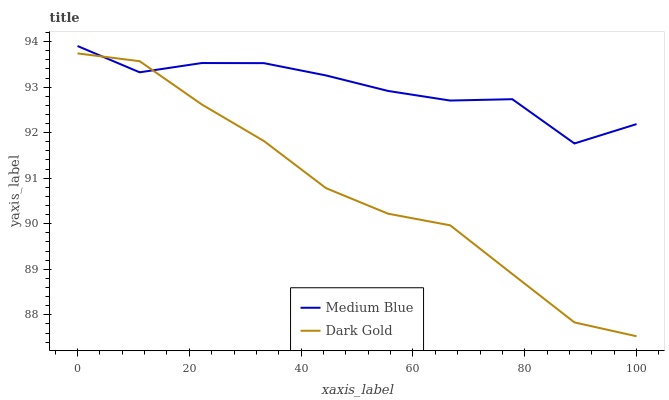Does Dark Gold have the minimum area under the curve?
Answer yes or no. Yes. Does Medium Blue have the maximum area under the curve?
Answer yes or no. Yes. Does Dark Gold have the maximum area under the curve?
Answer yes or no. No. Is Dark Gold the smoothest?
Answer yes or no. Yes. Is Medium Blue the roughest?
Answer yes or no. Yes. Is Dark Gold the roughest?
Answer yes or no. No. Does Dark Gold have the lowest value?
Answer yes or no. Yes. Does Medium Blue have the highest value?
Answer yes or no. Yes. Does Dark Gold have the highest value?
Answer yes or no. No. Does Medium Blue intersect Dark Gold?
Answer yes or no. Yes. Is Medium Blue less than Dark Gold?
Answer yes or no. No. Is Medium Blue greater than Dark Gold?
Answer yes or no. No. 